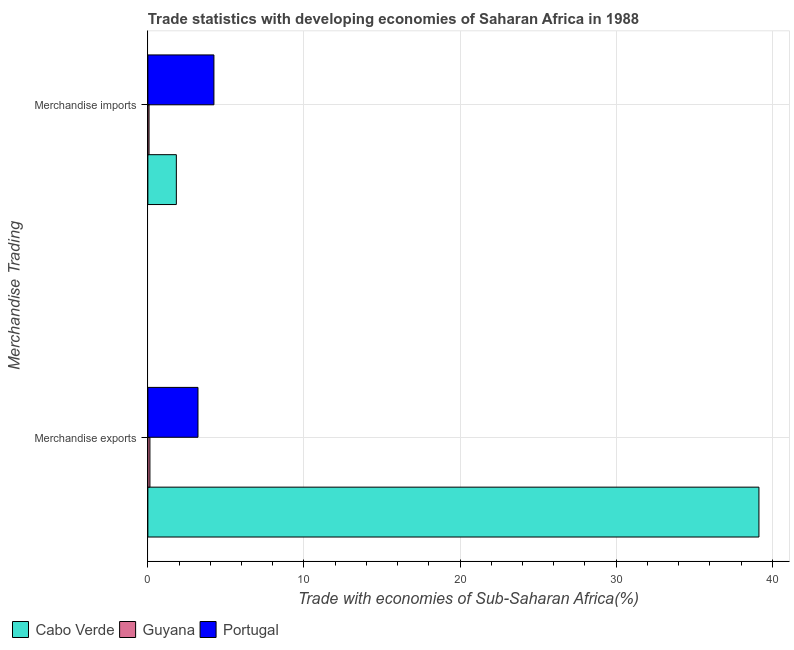How many different coloured bars are there?
Provide a succinct answer. 3. How many groups of bars are there?
Offer a very short reply. 2. How many bars are there on the 1st tick from the bottom?
Keep it short and to the point. 3. What is the label of the 1st group of bars from the top?
Your answer should be very brief. Merchandise imports. What is the merchandise imports in Cabo Verde?
Provide a succinct answer. 1.82. Across all countries, what is the maximum merchandise exports?
Ensure brevity in your answer.  39.15. Across all countries, what is the minimum merchandise exports?
Your response must be concise. 0.13. In which country was the merchandise exports maximum?
Ensure brevity in your answer.  Cabo Verde. In which country was the merchandise imports minimum?
Your answer should be compact. Guyana. What is the total merchandise exports in the graph?
Offer a very short reply. 42.49. What is the difference between the merchandise imports in Guyana and that in Portugal?
Offer a terse response. -4.16. What is the difference between the merchandise imports in Portugal and the merchandise exports in Cabo Verde?
Provide a succinct answer. -34.91. What is the average merchandise imports per country?
Keep it short and to the point. 2.04. What is the difference between the merchandise imports and merchandise exports in Portugal?
Keep it short and to the point. 1.02. In how many countries, is the merchandise imports greater than 18 %?
Offer a terse response. 0. What is the ratio of the merchandise imports in Guyana to that in Cabo Verde?
Your answer should be compact. 0.04. In how many countries, is the merchandise imports greater than the average merchandise imports taken over all countries?
Give a very brief answer. 1. What does the 3rd bar from the top in Merchandise imports represents?
Your answer should be compact. Cabo Verde. What does the 1st bar from the bottom in Merchandise exports represents?
Offer a very short reply. Cabo Verde. Are all the bars in the graph horizontal?
Your answer should be compact. Yes. Does the graph contain any zero values?
Offer a terse response. No. How many legend labels are there?
Keep it short and to the point. 3. How are the legend labels stacked?
Your response must be concise. Horizontal. What is the title of the graph?
Make the answer very short. Trade statistics with developing economies of Saharan Africa in 1988. What is the label or title of the X-axis?
Offer a very short reply. Trade with economies of Sub-Saharan Africa(%). What is the label or title of the Y-axis?
Your answer should be compact. Merchandise Trading. What is the Trade with economies of Sub-Saharan Africa(%) in Cabo Verde in Merchandise exports?
Ensure brevity in your answer.  39.15. What is the Trade with economies of Sub-Saharan Africa(%) of Guyana in Merchandise exports?
Your response must be concise. 0.13. What is the Trade with economies of Sub-Saharan Africa(%) in Portugal in Merchandise exports?
Offer a terse response. 3.21. What is the Trade with economies of Sub-Saharan Africa(%) of Cabo Verde in Merchandise imports?
Make the answer very short. 1.82. What is the Trade with economies of Sub-Saharan Africa(%) of Guyana in Merchandise imports?
Your answer should be very brief. 0.08. What is the Trade with economies of Sub-Saharan Africa(%) of Portugal in Merchandise imports?
Provide a short and direct response. 4.23. Across all Merchandise Trading, what is the maximum Trade with economies of Sub-Saharan Africa(%) in Cabo Verde?
Offer a very short reply. 39.15. Across all Merchandise Trading, what is the maximum Trade with economies of Sub-Saharan Africa(%) of Guyana?
Offer a very short reply. 0.13. Across all Merchandise Trading, what is the maximum Trade with economies of Sub-Saharan Africa(%) in Portugal?
Your answer should be very brief. 4.23. Across all Merchandise Trading, what is the minimum Trade with economies of Sub-Saharan Africa(%) of Cabo Verde?
Your answer should be very brief. 1.82. Across all Merchandise Trading, what is the minimum Trade with economies of Sub-Saharan Africa(%) of Guyana?
Give a very brief answer. 0.08. Across all Merchandise Trading, what is the minimum Trade with economies of Sub-Saharan Africa(%) of Portugal?
Your answer should be very brief. 3.21. What is the total Trade with economies of Sub-Saharan Africa(%) in Cabo Verde in the graph?
Your answer should be very brief. 40.97. What is the total Trade with economies of Sub-Saharan Africa(%) of Guyana in the graph?
Your response must be concise. 0.21. What is the total Trade with economies of Sub-Saharan Africa(%) in Portugal in the graph?
Ensure brevity in your answer.  7.44. What is the difference between the Trade with economies of Sub-Saharan Africa(%) in Cabo Verde in Merchandise exports and that in Merchandise imports?
Provide a short and direct response. 37.32. What is the difference between the Trade with economies of Sub-Saharan Africa(%) of Guyana in Merchandise exports and that in Merchandise imports?
Offer a very short reply. 0.06. What is the difference between the Trade with economies of Sub-Saharan Africa(%) in Portugal in Merchandise exports and that in Merchandise imports?
Provide a succinct answer. -1.02. What is the difference between the Trade with economies of Sub-Saharan Africa(%) in Cabo Verde in Merchandise exports and the Trade with economies of Sub-Saharan Africa(%) in Guyana in Merchandise imports?
Give a very brief answer. 39.07. What is the difference between the Trade with economies of Sub-Saharan Africa(%) in Cabo Verde in Merchandise exports and the Trade with economies of Sub-Saharan Africa(%) in Portugal in Merchandise imports?
Make the answer very short. 34.91. What is the difference between the Trade with economies of Sub-Saharan Africa(%) of Guyana in Merchandise exports and the Trade with economies of Sub-Saharan Africa(%) of Portugal in Merchandise imports?
Your response must be concise. -4.1. What is the average Trade with economies of Sub-Saharan Africa(%) in Cabo Verde per Merchandise Trading?
Provide a succinct answer. 20.48. What is the average Trade with economies of Sub-Saharan Africa(%) of Guyana per Merchandise Trading?
Provide a short and direct response. 0.1. What is the average Trade with economies of Sub-Saharan Africa(%) of Portugal per Merchandise Trading?
Make the answer very short. 3.72. What is the difference between the Trade with economies of Sub-Saharan Africa(%) of Cabo Verde and Trade with economies of Sub-Saharan Africa(%) of Guyana in Merchandise exports?
Provide a short and direct response. 39.01. What is the difference between the Trade with economies of Sub-Saharan Africa(%) in Cabo Verde and Trade with economies of Sub-Saharan Africa(%) in Portugal in Merchandise exports?
Offer a terse response. 35.93. What is the difference between the Trade with economies of Sub-Saharan Africa(%) of Guyana and Trade with economies of Sub-Saharan Africa(%) of Portugal in Merchandise exports?
Keep it short and to the point. -3.08. What is the difference between the Trade with economies of Sub-Saharan Africa(%) of Cabo Verde and Trade with economies of Sub-Saharan Africa(%) of Guyana in Merchandise imports?
Your answer should be compact. 1.75. What is the difference between the Trade with economies of Sub-Saharan Africa(%) in Cabo Verde and Trade with economies of Sub-Saharan Africa(%) in Portugal in Merchandise imports?
Give a very brief answer. -2.41. What is the difference between the Trade with economies of Sub-Saharan Africa(%) of Guyana and Trade with economies of Sub-Saharan Africa(%) of Portugal in Merchandise imports?
Ensure brevity in your answer.  -4.16. What is the ratio of the Trade with economies of Sub-Saharan Africa(%) of Cabo Verde in Merchandise exports to that in Merchandise imports?
Keep it short and to the point. 21.46. What is the ratio of the Trade with economies of Sub-Saharan Africa(%) in Guyana in Merchandise exports to that in Merchandise imports?
Provide a short and direct response. 1.74. What is the ratio of the Trade with economies of Sub-Saharan Africa(%) in Portugal in Merchandise exports to that in Merchandise imports?
Give a very brief answer. 0.76. What is the difference between the highest and the second highest Trade with economies of Sub-Saharan Africa(%) in Cabo Verde?
Your answer should be compact. 37.32. What is the difference between the highest and the second highest Trade with economies of Sub-Saharan Africa(%) of Guyana?
Provide a short and direct response. 0.06. What is the difference between the highest and the second highest Trade with economies of Sub-Saharan Africa(%) in Portugal?
Ensure brevity in your answer.  1.02. What is the difference between the highest and the lowest Trade with economies of Sub-Saharan Africa(%) of Cabo Verde?
Offer a terse response. 37.32. What is the difference between the highest and the lowest Trade with economies of Sub-Saharan Africa(%) in Guyana?
Offer a terse response. 0.06. What is the difference between the highest and the lowest Trade with economies of Sub-Saharan Africa(%) of Portugal?
Give a very brief answer. 1.02. 